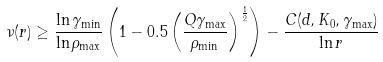<formula> <loc_0><loc_0><loc_500><loc_500>\nu ( r ) \geq \frac { \ln \gamma _ { \min } } { \ln \rho _ { \max } } \left ( 1 - 0 . 5 \left ( \frac { Q \gamma _ { \max } } { \rho _ { \min } } \right ) ^ { \frac { 1 } { 2 } } \right ) - \frac { C ( d , K _ { 0 } , \gamma _ { \max } ) } { \ln r }</formula> 